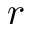Convert formula to latex. <formula><loc_0><loc_0><loc_500><loc_500>r</formula> 